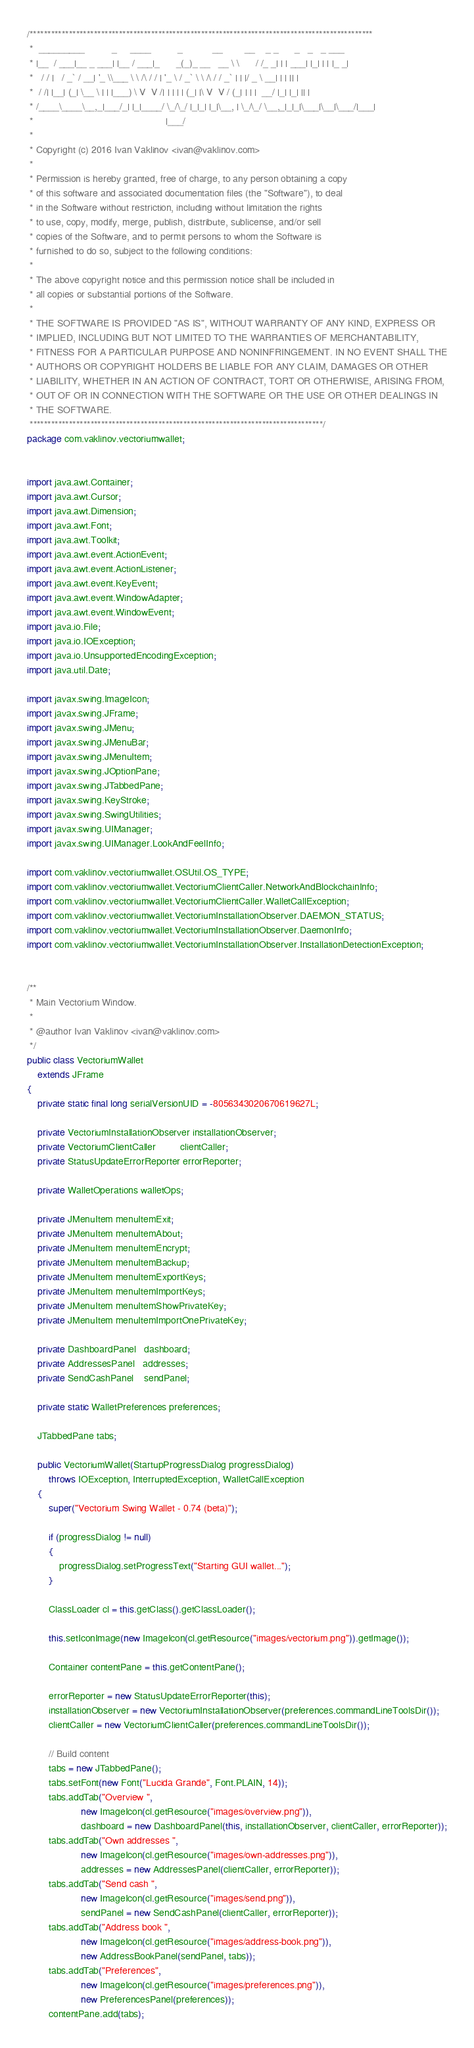<code> <loc_0><loc_0><loc_500><loc_500><_Java_>/************************************************************************************************
 *  _________          _     ____          _           __        __    _ _      _   _   _ ___
 * |__  / ___|__ _ ___| |__ / ___|_      _(_)_ __   __ \ \      / /_ _| | | ___| |_| | | |_ _|
 *   / / |   / _` / __| '_ \\___ \ \ /\ / / | '_ \ / _` \ \ /\ / / _` | | |/ _ \ __| | | || |
 *  / /| |__| (_| \__ \ | | |___) \ V  V /| | | | | (_| |\ V  V / (_| | | |  __/ |_| |_| || |
 * /____\____\__,_|___/_| |_|____/ \_/\_/ |_|_| |_|\__, | \_/\_/ \__,_|_|_|\___|\__|\___/|___|
 *                                                 |___/
 *
 * Copyright (c) 2016 Ivan Vaklinov <ivan@vaklinov.com>
 *
 * Permission is hereby granted, free of charge, to any person obtaining a copy
 * of this software and associated documentation files (the "Software"), to deal
 * in the Software without restriction, including without limitation the rights
 * to use, copy, modify, merge, publish, distribute, sublicense, and/or sell
 * copies of the Software, and to permit persons to whom the Software is
 * furnished to do so, subject to the following conditions:
 *
 * The above copyright notice and this permission notice shall be included in
 * all copies or substantial portions of the Software.
 *
 * THE SOFTWARE IS PROVIDED "AS IS", WITHOUT WARRANTY OF ANY KIND, EXPRESS OR
 * IMPLIED, INCLUDING BUT NOT LIMITED TO THE WARRANTIES OF MERCHANTABILITY,
 * FITNESS FOR A PARTICULAR PURPOSE AND NONINFRINGEMENT. IN NO EVENT SHALL THE
 * AUTHORS OR COPYRIGHT HOLDERS BE LIABLE FOR ANY CLAIM, DAMAGES OR OTHER
 * LIABILITY, WHETHER IN AN ACTION OF CONTRACT, TORT OR OTHERWISE, ARISING FROM,
 * OUT OF OR IN CONNECTION WITH THE SOFTWARE OR THE USE OR OTHER DEALINGS IN
 * THE SOFTWARE.
 **********************************************************************************/
package com.vaklinov.vectoriumwallet;


import java.awt.Container;
import java.awt.Cursor;
import java.awt.Dimension;
import java.awt.Font;
import java.awt.Toolkit;
import java.awt.event.ActionEvent;
import java.awt.event.ActionListener;
import java.awt.event.KeyEvent;
import java.awt.event.WindowAdapter;
import java.awt.event.WindowEvent;
import java.io.File;
import java.io.IOException;
import java.io.UnsupportedEncodingException;
import java.util.Date;

import javax.swing.ImageIcon;
import javax.swing.JFrame;
import javax.swing.JMenu;
import javax.swing.JMenuBar;
import javax.swing.JMenuItem;
import javax.swing.JOptionPane;
import javax.swing.JTabbedPane;
import javax.swing.KeyStroke;
import javax.swing.SwingUtilities;
import javax.swing.UIManager;
import javax.swing.UIManager.LookAndFeelInfo;

import com.vaklinov.vectoriumwallet.OSUtil.OS_TYPE;
import com.vaklinov.vectoriumwallet.VectoriumClientCaller.NetworkAndBlockchainInfo;
import com.vaklinov.vectoriumwallet.VectoriumClientCaller.WalletCallException;
import com.vaklinov.vectoriumwallet.VectoriumInstallationObserver.DAEMON_STATUS;
import com.vaklinov.vectoriumwallet.VectoriumInstallationObserver.DaemonInfo;
import com.vaklinov.vectoriumwallet.VectoriumInstallationObserver.InstallationDetectionException;


/**
 * Main Vectorium Window.
 *
 * @author Ivan Vaklinov <ivan@vaklinov.com>
 */
public class VectoriumWallet
    extends JFrame
{
	private static final long serialVersionUID = -8056343020670619627L;

	private VectoriumInstallationObserver installationObserver;
    private VectoriumClientCaller         clientCaller;
    private StatusUpdateErrorReporter errorReporter;

    private WalletOperations walletOps;

    private JMenuItem menuItemExit;
    private JMenuItem menuItemAbout;
    private JMenuItem menuItemEncrypt;
    private JMenuItem menuItemBackup;
    private JMenuItem menuItemExportKeys;
    private JMenuItem menuItemImportKeys;
    private JMenuItem menuItemShowPrivateKey;
    private JMenuItem menuItemImportOnePrivateKey;

    private DashboardPanel   dashboard;
    private AddressesPanel   addresses;
    private SendCashPanel    sendPanel;
    
    private static WalletPreferences preferences;
    
    JTabbedPane tabs;

    public VectoriumWallet(StartupProgressDialog progressDialog)
        throws IOException, InterruptedException, WalletCallException
    {
        super("Vectorium Swing Wallet - 0.74 (beta)");
        
        if (progressDialog != null)
        {
        	progressDialog.setProgressText("Starting GUI wallet...");
        }
        
        ClassLoader cl = this.getClass().getClassLoader();

        this.setIconImage(new ImageIcon(cl.getResource("images/vectorium.png")).getImage());

        Container contentPane = this.getContentPane();

        errorReporter = new StatusUpdateErrorReporter(this);
        installationObserver = new VectoriumInstallationObserver(preferences.commandLineToolsDir());
        clientCaller = new VectoriumClientCaller(preferences.commandLineToolsDir());

        // Build content
        tabs = new JTabbedPane();
        tabs.setFont(new Font("Lucida Grande", Font.PLAIN, 14));
        tabs.addTab("Overview ",
        		    new ImageIcon(cl.getResource("images/overview.png")),
        		    dashboard = new DashboardPanel(this, installationObserver, clientCaller, errorReporter));
        tabs.addTab("Own addresses ",
        		    new ImageIcon(cl.getResource("images/own-addresses.png")),
        		    addresses = new AddressesPanel(clientCaller, errorReporter));
        tabs.addTab("Send cash ",
        		    new ImageIcon(cl.getResource("images/send.png")),
        		    sendPanel = new SendCashPanel(clientCaller, errorReporter));
        tabs.addTab("Address book ",
    		        new ImageIcon(cl.getResource("images/address-book.png")),
    		        new AddressBookPanel(sendPanel, tabs));
        tabs.addTab("Preferences",
	        		new ImageIcon(cl.getResource("images/preferences.png")),
    				new PreferencesPanel(preferences));
        contentPane.add(tabs);
</code> 